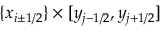<formula> <loc_0><loc_0><loc_500><loc_500>\{ x _ { i \pm 1 / 2 } \} \times [ y _ { j - 1 / 2 } , y _ { j + 1 / 2 } ]</formula> 